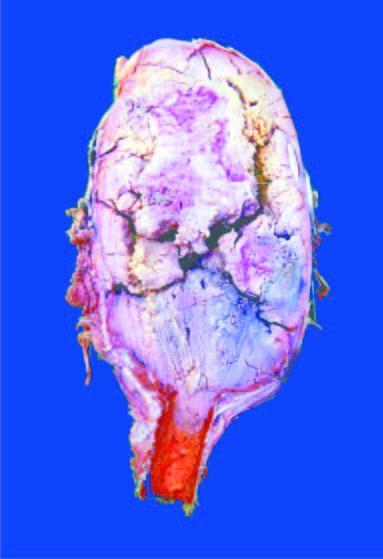s viral dna expanded in the region of epiphysis?
Answer the question using a single word or phrase. No 